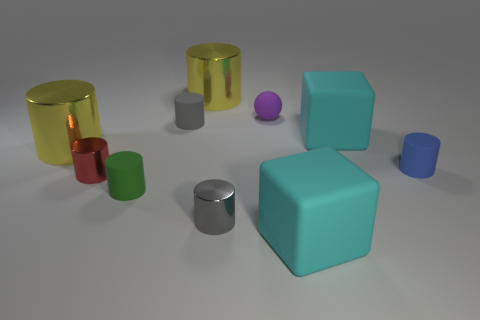Subtract all green cylinders. How many cylinders are left? 6 Subtract all tiny gray rubber cylinders. How many cylinders are left? 6 Subtract 1 cylinders. How many cylinders are left? 6 Subtract all red cylinders. Subtract all yellow blocks. How many cylinders are left? 6 Subtract all balls. How many objects are left? 9 Add 6 big yellow shiny cylinders. How many big yellow shiny cylinders are left? 8 Add 10 large brown shiny objects. How many large brown shiny objects exist? 10 Subtract 0 purple cubes. How many objects are left? 10 Subtract all big cyan cubes. Subtract all gray matte things. How many objects are left? 7 